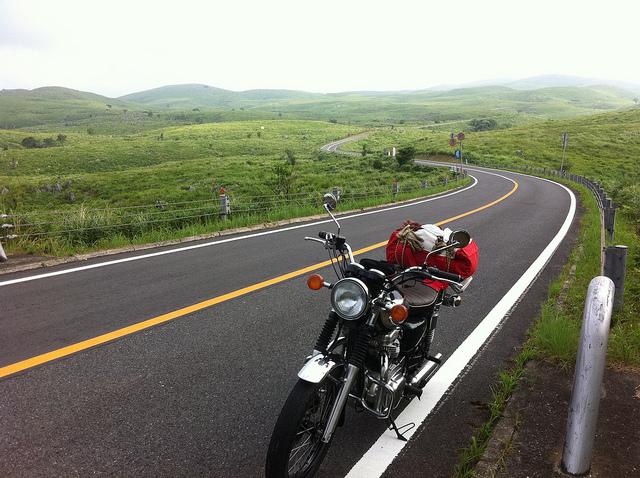Is the terrain hilly or flat?
Give a very brief answer. Hilly. What color is the top of the fence pole on the opposite side of the road?
Be succinct. Red. What color stripe runs down the middle of the roadway?
Be succinct. Yellow. 